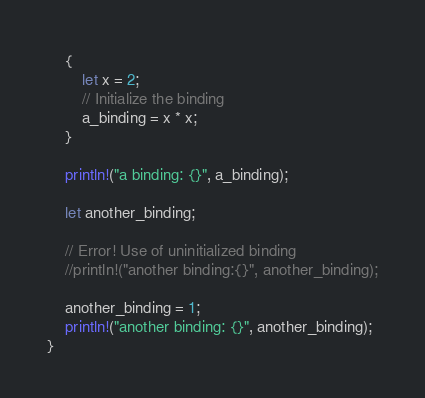<code> <loc_0><loc_0><loc_500><loc_500><_Rust_>
    {
        let x = 2;
        // Initialize the binding
        a_binding = x * x;
    }

    println!("a binding: {}", a_binding);

    let another_binding;

    // Error! Use of uninitialized binding
    //println!("another binding:{}", another_binding);

    another_binding = 1;
    println!("another binding: {}", another_binding);
}
</code> 